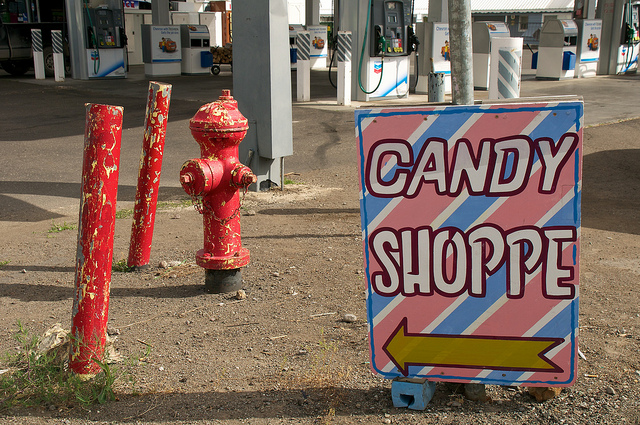<image>Why is the sign near the dog in German? It is unclear why the sign near the dog is in German, because there is no dog in the image. Why is the sign near the dog in German? I don't know why the sign near the dog is in German. It may not actually be in German or there may not be a dog at all. 